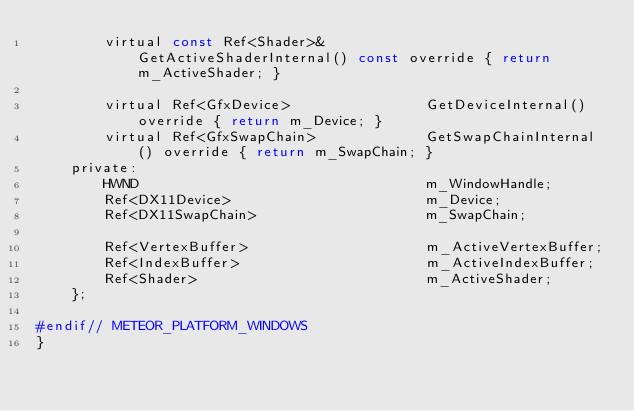Convert code to text. <code><loc_0><loc_0><loc_500><loc_500><_C_>        virtual const Ref<Shader>&            GetActiveShaderInternal() const override { return m_ActiveShader; }

        virtual Ref<GfxDevice>                GetDeviceInternal() override { return m_Device; }
        virtual Ref<GfxSwapChain>             GetSwapChainInternal() override { return m_SwapChain; }
    private:
        HWND                                  m_WindowHandle;
        Ref<DX11Device>                       m_Device;
        Ref<DX11SwapChain>                    m_SwapChain;

        Ref<VertexBuffer>                     m_ActiveVertexBuffer;
        Ref<IndexBuffer>                      m_ActiveIndexBuffer;
        Ref<Shader>                           m_ActiveShader;
    };

#endif// METEOR_PLATFORM_WINDOWS
}</code> 